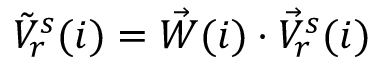<formula> <loc_0><loc_0><loc_500><loc_500>\begin{array} { r } { \tilde { V } _ { r } ^ { s } ( i ) = \vec { W } ( i ) \cdot \vec { V } _ { r } ^ { s } ( i ) } \end{array}</formula> 